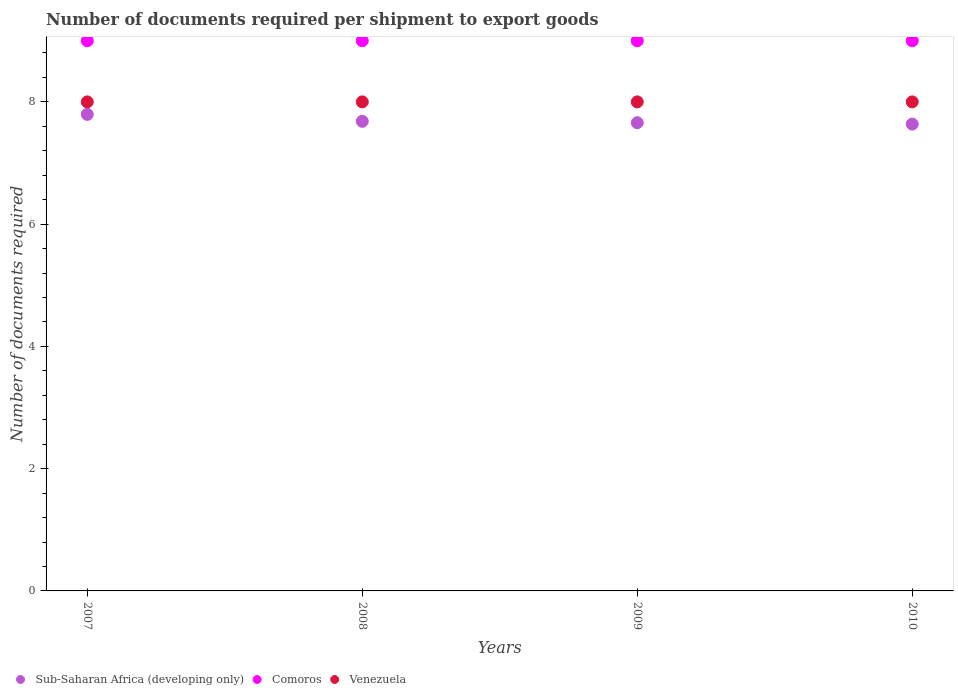How many different coloured dotlines are there?
Provide a short and direct response. 3. Is the number of dotlines equal to the number of legend labels?
Provide a succinct answer. Yes. What is the number of documents required per shipment to export goods in Sub-Saharan Africa (developing only) in 2007?
Keep it short and to the point. 7.8. Across all years, what is the maximum number of documents required per shipment to export goods in Comoros?
Keep it short and to the point. 9. Across all years, what is the minimum number of documents required per shipment to export goods in Sub-Saharan Africa (developing only)?
Make the answer very short. 7.64. In which year was the number of documents required per shipment to export goods in Comoros maximum?
Your answer should be compact. 2007. In which year was the number of documents required per shipment to export goods in Sub-Saharan Africa (developing only) minimum?
Provide a succinct answer. 2010. What is the total number of documents required per shipment to export goods in Sub-Saharan Africa (developing only) in the graph?
Your response must be concise. 30.77. What is the difference between the number of documents required per shipment to export goods in Comoros in 2007 and the number of documents required per shipment to export goods in Venezuela in 2009?
Keep it short and to the point. 1. In the year 2010, what is the difference between the number of documents required per shipment to export goods in Venezuela and number of documents required per shipment to export goods in Comoros?
Make the answer very short. -1. What is the ratio of the number of documents required per shipment to export goods in Venezuela in 2007 to that in 2008?
Ensure brevity in your answer.  1. What is the difference between the highest and the second highest number of documents required per shipment to export goods in Comoros?
Provide a short and direct response. 0. What is the difference between the highest and the lowest number of documents required per shipment to export goods in Sub-Saharan Africa (developing only)?
Keep it short and to the point. 0.16. In how many years, is the number of documents required per shipment to export goods in Venezuela greater than the average number of documents required per shipment to export goods in Venezuela taken over all years?
Make the answer very short. 0. Is the sum of the number of documents required per shipment to export goods in Venezuela in 2008 and 2009 greater than the maximum number of documents required per shipment to export goods in Sub-Saharan Africa (developing only) across all years?
Ensure brevity in your answer.  Yes. Does the number of documents required per shipment to export goods in Venezuela monotonically increase over the years?
Provide a succinct answer. No. How many dotlines are there?
Your answer should be very brief. 3. How many years are there in the graph?
Keep it short and to the point. 4. What is the difference between two consecutive major ticks on the Y-axis?
Keep it short and to the point. 2. Are the values on the major ticks of Y-axis written in scientific E-notation?
Give a very brief answer. No. Where does the legend appear in the graph?
Offer a terse response. Bottom left. What is the title of the graph?
Keep it short and to the point. Number of documents required per shipment to export goods. What is the label or title of the Y-axis?
Make the answer very short. Number of documents required. What is the Number of documents required in Sub-Saharan Africa (developing only) in 2007?
Give a very brief answer. 7.8. What is the Number of documents required of Sub-Saharan Africa (developing only) in 2008?
Provide a short and direct response. 7.68. What is the Number of documents required in Sub-Saharan Africa (developing only) in 2009?
Make the answer very short. 7.66. What is the Number of documents required in Comoros in 2009?
Your answer should be very brief. 9. What is the Number of documents required in Sub-Saharan Africa (developing only) in 2010?
Ensure brevity in your answer.  7.64. What is the Number of documents required of Comoros in 2010?
Your response must be concise. 9. Across all years, what is the maximum Number of documents required in Sub-Saharan Africa (developing only)?
Your answer should be compact. 7.8. Across all years, what is the maximum Number of documents required in Comoros?
Offer a very short reply. 9. Across all years, what is the minimum Number of documents required in Sub-Saharan Africa (developing only)?
Give a very brief answer. 7.64. Across all years, what is the minimum Number of documents required of Comoros?
Keep it short and to the point. 9. What is the total Number of documents required of Sub-Saharan Africa (developing only) in the graph?
Keep it short and to the point. 30.77. What is the total Number of documents required in Comoros in the graph?
Ensure brevity in your answer.  36. What is the difference between the Number of documents required of Sub-Saharan Africa (developing only) in 2007 and that in 2008?
Ensure brevity in your answer.  0.11. What is the difference between the Number of documents required of Sub-Saharan Africa (developing only) in 2007 and that in 2009?
Keep it short and to the point. 0.14. What is the difference between the Number of documents required in Venezuela in 2007 and that in 2009?
Provide a short and direct response. 0. What is the difference between the Number of documents required of Sub-Saharan Africa (developing only) in 2007 and that in 2010?
Your response must be concise. 0.16. What is the difference between the Number of documents required of Comoros in 2007 and that in 2010?
Offer a terse response. 0. What is the difference between the Number of documents required of Venezuela in 2007 and that in 2010?
Offer a terse response. 0. What is the difference between the Number of documents required in Sub-Saharan Africa (developing only) in 2008 and that in 2009?
Give a very brief answer. 0.02. What is the difference between the Number of documents required in Comoros in 2008 and that in 2009?
Ensure brevity in your answer.  0. What is the difference between the Number of documents required in Sub-Saharan Africa (developing only) in 2008 and that in 2010?
Your response must be concise. 0.05. What is the difference between the Number of documents required in Comoros in 2008 and that in 2010?
Make the answer very short. 0. What is the difference between the Number of documents required in Sub-Saharan Africa (developing only) in 2009 and that in 2010?
Make the answer very short. 0.02. What is the difference between the Number of documents required of Comoros in 2009 and that in 2010?
Give a very brief answer. 0. What is the difference between the Number of documents required of Sub-Saharan Africa (developing only) in 2007 and the Number of documents required of Comoros in 2008?
Your answer should be compact. -1.2. What is the difference between the Number of documents required of Sub-Saharan Africa (developing only) in 2007 and the Number of documents required of Venezuela in 2008?
Offer a terse response. -0.2. What is the difference between the Number of documents required of Comoros in 2007 and the Number of documents required of Venezuela in 2008?
Your answer should be compact. 1. What is the difference between the Number of documents required in Sub-Saharan Africa (developing only) in 2007 and the Number of documents required in Comoros in 2009?
Keep it short and to the point. -1.2. What is the difference between the Number of documents required in Sub-Saharan Africa (developing only) in 2007 and the Number of documents required in Venezuela in 2009?
Give a very brief answer. -0.2. What is the difference between the Number of documents required in Comoros in 2007 and the Number of documents required in Venezuela in 2009?
Offer a very short reply. 1. What is the difference between the Number of documents required in Sub-Saharan Africa (developing only) in 2007 and the Number of documents required in Comoros in 2010?
Provide a short and direct response. -1.2. What is the difference between the Number of documents required of Sub-Saharan Africa (developing only) in 2007 and the Number of documents required of Venezuela in 2010?
Make the answer very short. -0.2. What is the difference between the Number of documents required in Comoros in 2007 and the Number of documents required in Venezuela in 2010?
Offer a very short reply. 1. What is the difference between the Number of documents required of Sub-Saharan Africa (developing only) in 2008 and the Number of documents required of Comoros in 2009?
Your answer should be very brief. -1.32. What is the difference between the Number of documents required of Sub-Saharan Africa (developing only) in 2008 and the Number of documents required of Venezuela in 2009?
Provide a short and direct response. -0.32. What is the difference between the Number of documents required in Comoros in 2008 and the Number of documents required in Venezuela in 2009?
Your answer should be very brief. 1. What is the difference between the Number of documents required in Sub-Saharan Africa (developing only) in 2008 and the Number of documents required in Comoros in 2010?
Your answer should be very brief. -1.32. What is the difference between the Number of documents required of Sub-Saharan Africa (developing only) in 2008 and the Number of documents required of Venezuela in 2010?
Your answer should be very brief. -0.32. What is the difference between the Number of documents required of Sub-Saharan Africa (developing only) in 2009 and the Number of documents required of Comoros in 2010?
Offer a terse response. -1.34. What is the difference between the Number of documents required in Sub-Saharan Africa (developing only) in 2009 and the Number of documents required in Venezuela in 2010?
Your answer should be very brief. -0.34. What is the average Number of documents required in Sub-Saharan Africa (developing only) per year?
Your answer should be very brief. 7.69. What is the average Number of documents required in Comoros per year?
Offer a terse response. 9. In the year 2007, what is the difference between the Number of documents required of Sub-Saharan Africa (developing only) and Number of documents required of Comoros?
Give a very brief answer. -1.2. In the year 2007, what is the difference between the Number of documents required of Sub-Saharan Africa (developing only) and Number of documents required of Venezuela?
Give a very brief answer. -0.2. In the year 2007, what is the difference between the Number of documents required in Comoros and Number of documents required in Venezuela?
Ensure brevity in your answer.  1. In the year 2008, what is the difference between the Number of documents required in Sub-Saharan Africa (developing only) and Number of documents required in Comoros?
Ensure brevity in your answer.  -1.32. In the year 2008, what is the difference between the Number of documents required of Sub-Saharan Africa (developing only) and Number of documents required of Venezuela?
Your response must be concise. -0.32. In the year 2008, what is the difference between the Number of documents required in Comoros and Number of documents required in Venezuela?
Your answer should be compact. 1. In the year 2009, what is the difference between the Number of documents required in Sub-Saharan Africa (developing only) and Number of documents required in Comoros?
Make the answer very short. -1.34. In the year 2009, what is the difference between the Number of documents required of Sub-Saharan Africa (developing only) and Number of documents required of Venezuela?
Give a very brief answer. -0.34. In the year 2010, what is the difference between the Number of documents required of Sub-Saharan Africa (developing only) and Number of documents required of Comoros?
Offer a very short reply. -1.36. In the year 2010, what is the difference between the Number of documents required in Sub-Saharan Africa (developing only) and Number of documents required in Venezuela?
Ensure brevity in your answer.  -0.36. In the year 2010, what is the difference between the Number of documents required in Comoros and Number of documents required in Venezuela?
Provide a short and direct response. 1. What is the ratio of the Number of documents required of Sub-Saharan Africa (developing only) in 2007 to that in 2008?
Provide a short and direct response. 1.01. What is the ratio of the Number of documents required in Venezuela in 2007 to that in 2008?
Your answer should be compact. 1. What is the ratio of the Number of documents required of Sub-Saharan Africa (developing only) in 2007 to that in 2009?
Give a very brief answer. 1.02. What is the ratio of the Number of documents required in Comoros in 2007 to that in 2009?
Offer a terse response. 1. What is the ratio of the Number of documents required in Sub-Saharan Africa (developing only) in 2007 to that in 2010?
Offer a terse response. 1.02. What is the ratio of the Number of documents required of Venezuela in 2007 to that in 2010?
Offer a very short reply. 1. What is the ratio of the Number of documents required in Sub-Saharan Africa (developing only) in 2008 to that in 2009?
Your answer should be compact. 1. What is the ratio of the Number of documents required of Sub-Saharan Africa (developing only) in 2008 to that in 2010?
Keep it short and to the point. 1.01. What is the ratio of the Number of documents required in Sub-Saharan Africa (developing only) in 2009 to that in 2010?
Give a very brief answer. 1. What is the ratio of the Number of documents required of Comoros in 2009 to that in 2010?
Provide a succinct answer. 1. What is the ratio of the Number of documents required of Venezuela in 2009 to that in 2010?
Keep it short and to the point. 1. What is the difference between the highest and the second highest Number of documents required of Sub-Saharan Africa (developing only)?
Give a very brief answer. 0.11. What is the difference between the highest and the second highest Number of documents required of Venezuela?
Keep it short and to the point. 0. What is the difference between the highest and the lowest Number of documents required in Sub-Saharan Africa (developing only)?
Make the answer very short. 0.16. What is the difference between the highest and the lowest Number of documents required of Comoros?
Make the answer very short. 0. What is the difference between the highest and the lowest Number of documents required in Venezuela?
Your answer should be very brief. 0. 